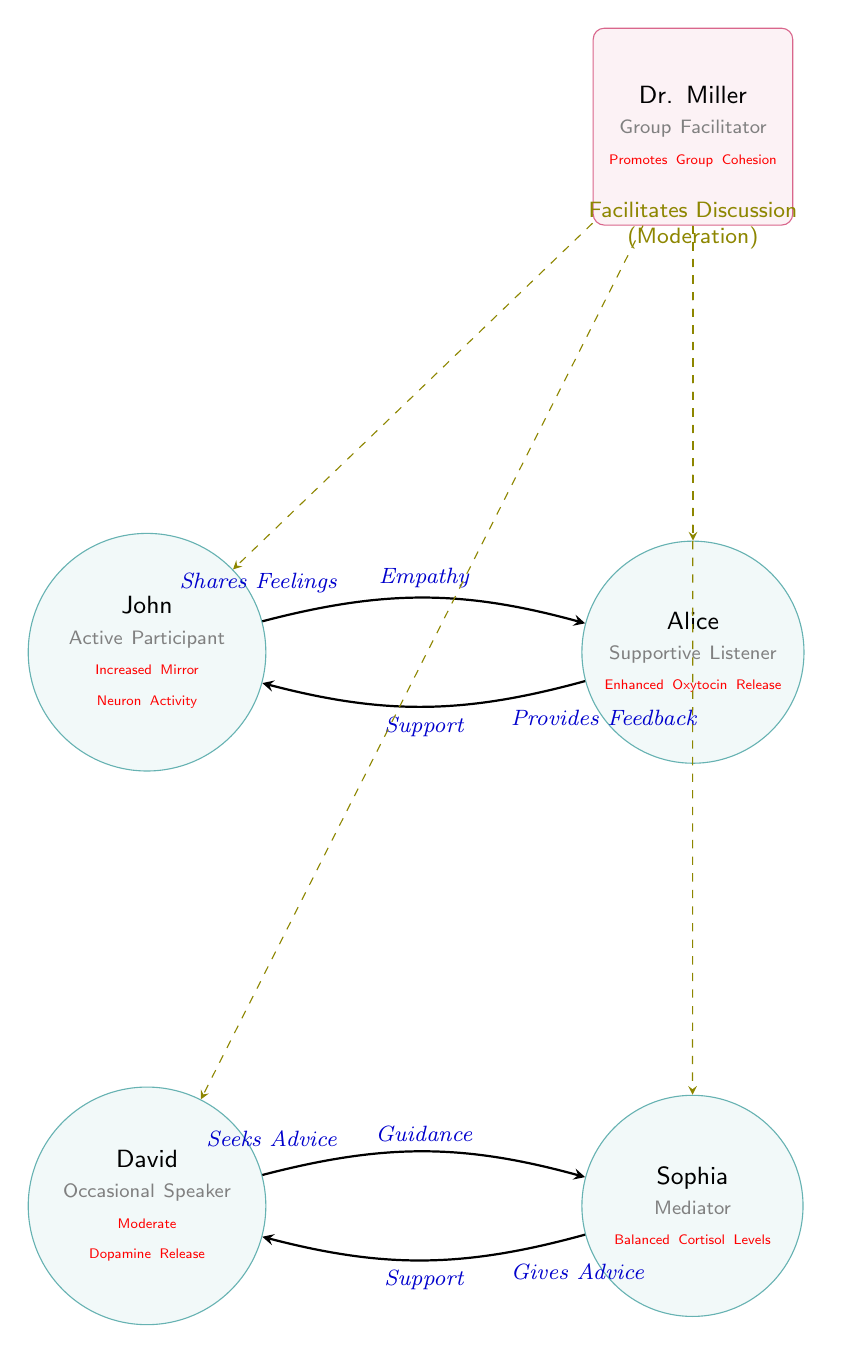What is the total number of nodes in the diagram? The diagram includes five nodes: John, Alice, David, Sophia, and Dr. Miller, which are all identified as participants or the therapist in the group therapy setting.
Answer: 5 Who is the group facilitator in the diagram? Dr. Miller is identified as the group facilitator, represented by the rectangular node at the top of the diagram.
Answer: Dr. Miller Which person in the diagram is labeled as an "Active Participant"? The label "Active Participant" is assigned to John, who is represented in the diagram by his circular node.
Answer: John What type of relationship does John have with Alice? The diagram indicates that John shares his feelings with Alice, characterized by the arrow labeled "Empathy" connecting them.
Answer: Shares Feelings How many edges are represented in the diagram? The diagram shows four edges, indicating the connections or relationships between the individuals: John to Alice, Alice to John, David to Sophia, and Sophia to David.
Answer: 4 What is the biological basis mentioned for Alice's role in the group? The diagram notes that Alice has an "Enhanced Oxytocin Release" as her biological basis, highlighting her supportive role in fostering connections.
Answer: Enhanced Oxytocin Release What prompts David to seek advice in the diagram? David seeks advice from Sophia, as indicated by the relationship labeled "Seeks Advice", emphasizing the connection built on guidance.
Answer: Seeks Advice How does Dr. Miller contribute to the group dynamics? Dr. Miller promotes group cohesion, which is underscored in the diagram as a function of his facilitative role in the therapy setting.
Answer: Promotes Group Cohesion What type of node represents therapists in the diagram? Therapists in the diagram are represented by a rectangle with rounded corners, as seen with Dr. Miller, differentiating him from the participant nodes.
Answer: Rectangle, rounded corners 